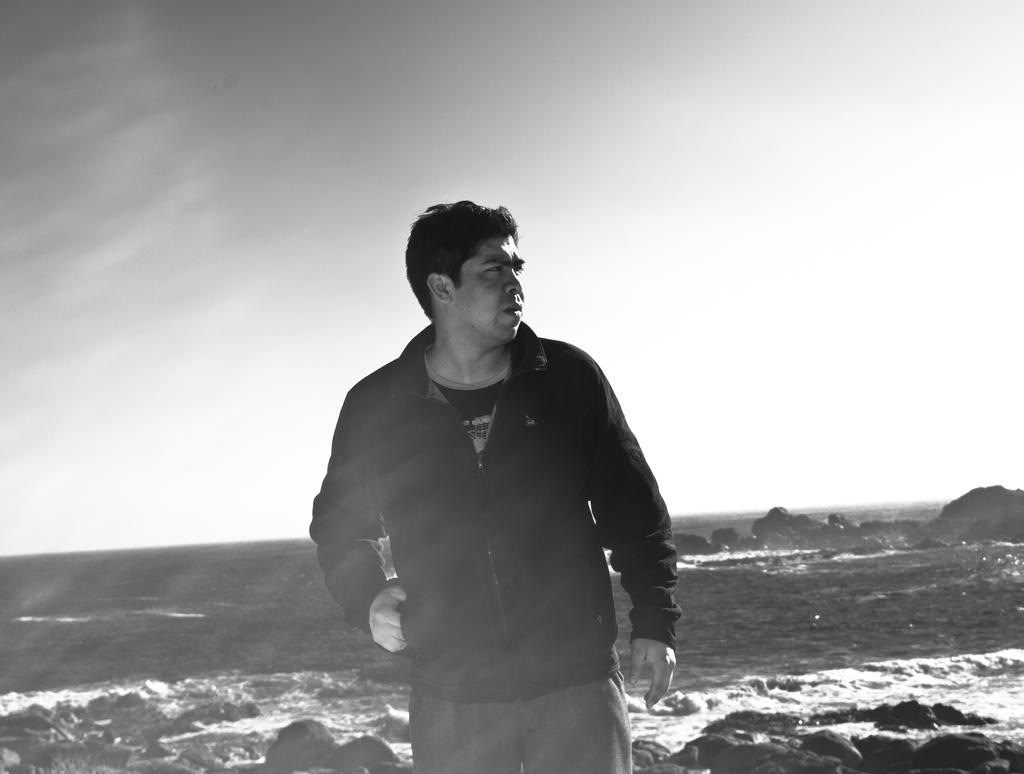What is the main subject of the image? There is a man standing in the image. Where is the man standing? The man is standing on the ground. What can be seen in the sky in the image? The sky is visible in the image, and there are clouds in the sky. What is present in the background of the image? Rocks and water are visible in the background of the image. What type of zinc is being tested by the man in the image? There is no zinc or testing activity present in the image; it features a man standing on the ground with a visible sky, clouds, rocks, and water in the background. 